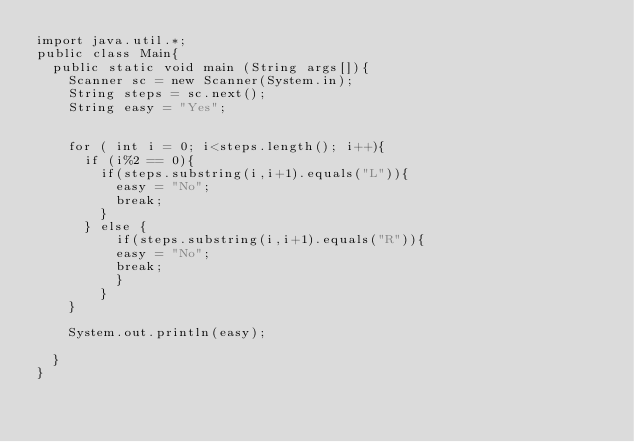Convert code to text. <code><loc_0><loc_0><loc_500><loc_500><_Java_>import java.util.*;
public class Main{
  public static void main (String args[]){
    Scanner sc = new Scanner(System.in);
    String steps = sc.next();
    String easy = "Yes";
    
    
    for ( int i = 0; i<steps.length(); i++){
      if (i%2 == 0){
        if(steps.substring(i,i+1).equals("L")){
          easy = "No";
          break;
        }
      } else {
          if(steps.substring(i,i+1).equals("R")){
          easy = "No";
          break;
          }
        }
    }
    
    System.out.println(easy);
    
  }
}
</code> 